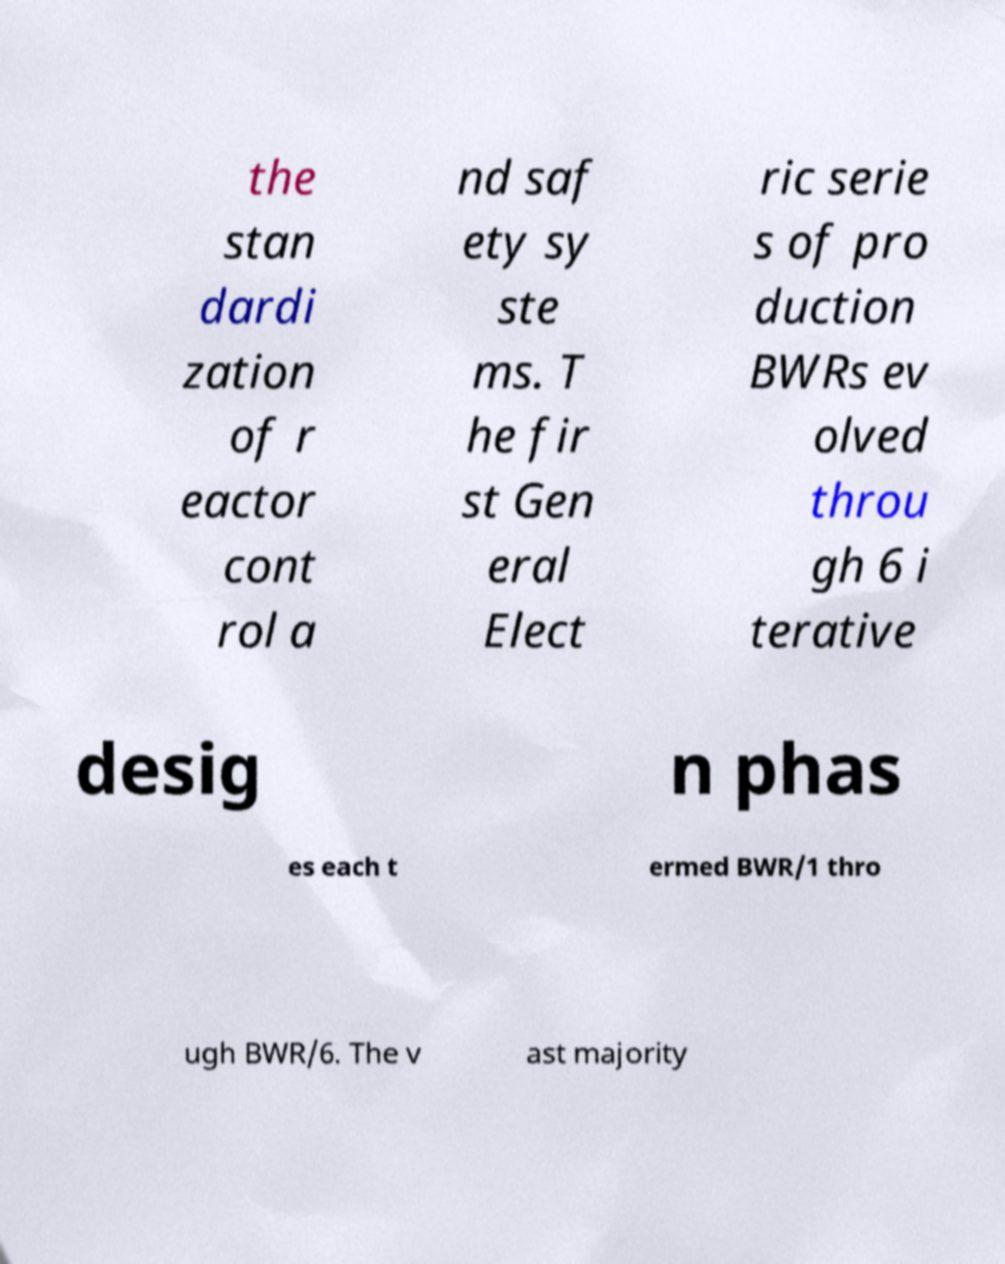Could you assist in decoding the text presented in this image and type it out clearly? the stan dardi zation of r eactor cont rol a nd saf ety sy ste ms. T he fir st Gen eral Elect ric serie s of pro duction BWRs ev olved throu gh 6 i terative desig n phas es each t ermed BWR/1 thro ugh BWR/6. The v ast majority 